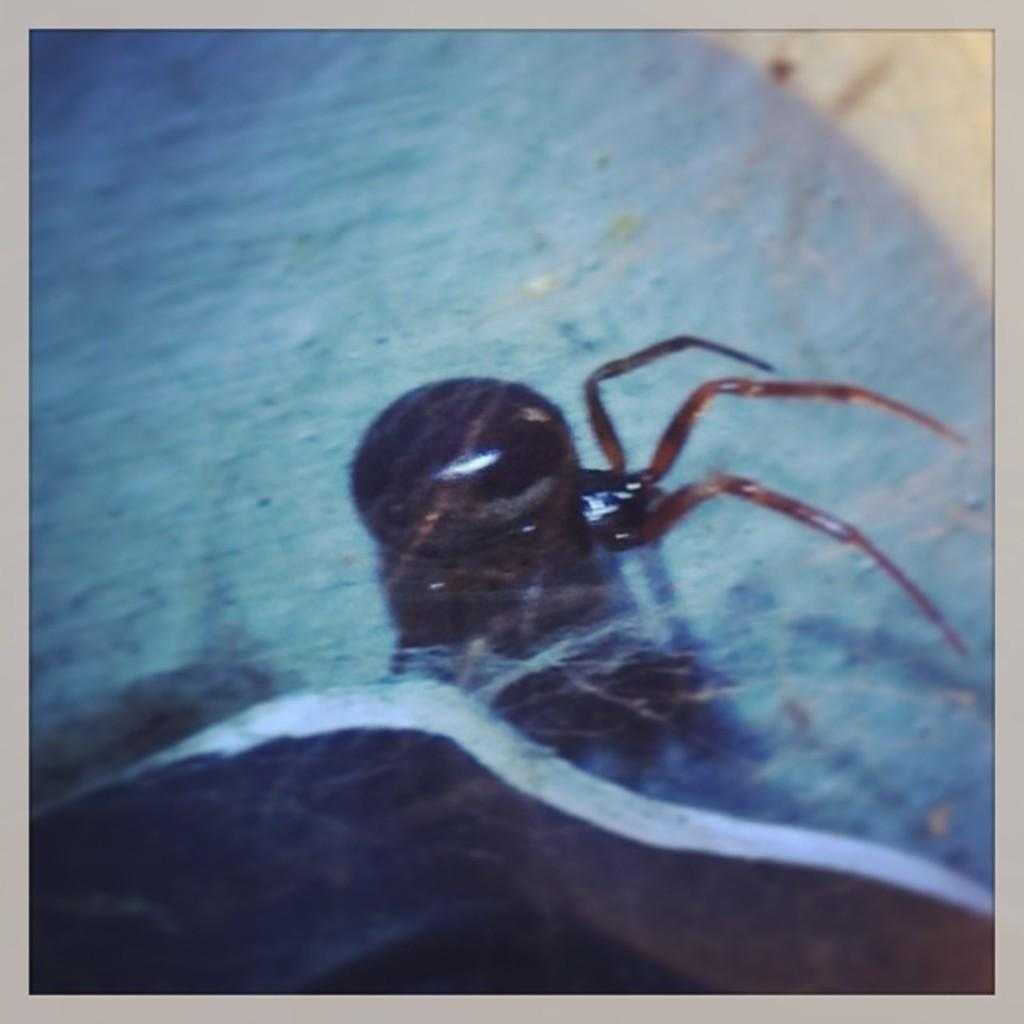What type of creature is present in the image? There is an insect in the image. What is the level of pollution in the image? There is no information about pollution in the image, as it only features an insect. How many pigs are visible in the image? There are no pigs present in the image; it only features an insect. 